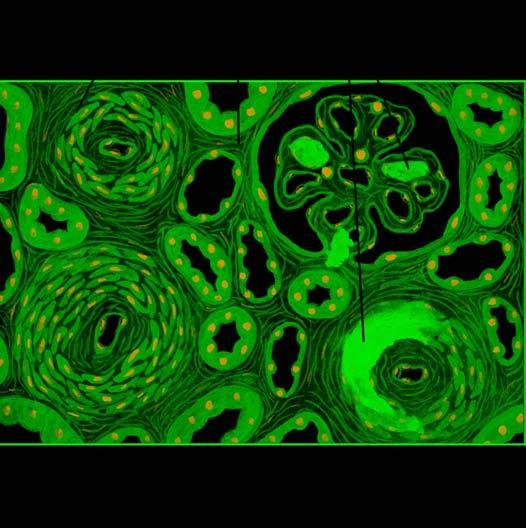what are tubular loss, fine interstitial fibrosis and foci of infarction necrosis?
Answer the question using a single word or phrase. Parenchymal changes 